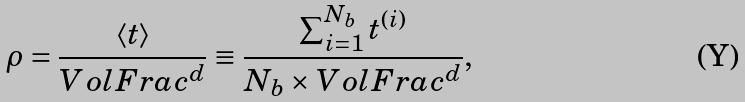Convert formula to latex. <formula><loc_0><loc_0><loc_500><loc_500>\rho = \frac { \langle t \rangle } { V o l F r a c ^ { d } } \equiv \frac { \sum _ { i = 1 } ^ { N _ { b } } t ^ { ( i ) } } { N _ { b } \times V o l F r a c ^ { d } } ,</formula> 